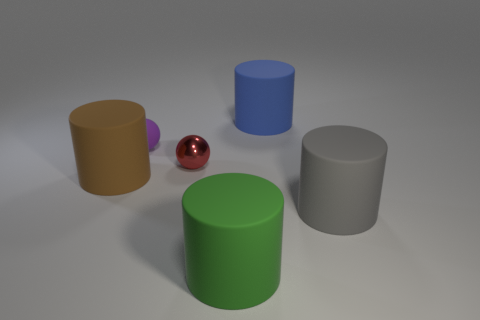Are there the same number of large green matte objects left of the large brown rubber cylinder and big brown matte things to the right of the blue object?
Offer a very short reply. Yes. What number of other objects are there of the same color as the small matte object?
Ensure brevity in your answer.  0. Are there an equal number of metal spheres that are to the right of the large blue rubber object and big blue rubber cylinders?
Your answer should be very brief. No. Is the size of the blue object the same as the green cylinder?
Your answer should be compact. Yes. There is a cylinder that is behind the gray object and in front of the small matte ball; what is its material?
Ensure brevity in your answer.  Rubber. What number of small green matte objects have the same shape as the gray object?
Your response must be concise. 0. There is a big cylinder on the right side of the blue cylinder; what is its material?
Provide a succinct answer. Rubber. Is the number of purple matte things on the left side of the large brown matte object less than the number of red balls?
Offer a very short reply. Yes. Is the purple rubber object the same shape as the big brown thing?
Offer a terse response. No. Is there anything else that has the same shape as the gray thing?
Your answer should be very brief. Yes. 